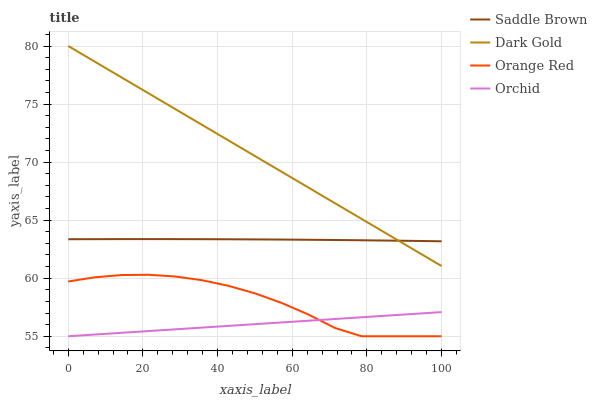Does Orchid have the minimum area under the curve?
Answer yes or no. Yes. Does Dark Gold have the maximum area under the curve?
Answer yes or no. Yes. Does Saddle Brown have the minimum area under the curve?
Answer yes or no. No. Does Saddle Brown have the maximum area under the curve?
Answer yes or no. No. Is Orchid the smoothest?
Answer yes or no. Yes. Is Orange Red the roughest?
Answer yes or no. Yes. Is Saddle Brown the smoothest?
Answer yes or no. No. Is Saddle Brown the roughest?
Answer yes or no. No. Does Orchid have the lowest value?
Answer yes or no. Yes. Does Saddle Brown have the lowest value?
Answer yes or no. No. Does Dark Gold have the highest value?
Answer yes or no. Yes. Does Saddle Brown have the highest value?
Answer yes or no. No. Is Orange Red less than Saddle Brown?
Answer yes or no. Yes. Is Dark Gold greater than Orange Red?
Answer yes or no. Yes. Does Dark Gold intersect Saddle Brown?
Answer yes or no. Yes. Is Dark Gold less than Saddle Brown?
Answer yes or no. No. Is Dark Gold greater than Saddle Brown?
Answer yes or no. No. Does Orange Red intersect Saddle Brown?
Answer yes or no. No. 